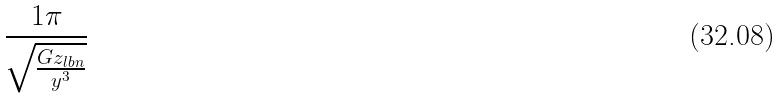Convert formula to latex. <formula><loc_0><loc_0><loc_500><loc_500>\frac { 1 \pi } { \sqrt { \frac { G z _ { l b n } } { y ^ { 3 } } } }</formula> 